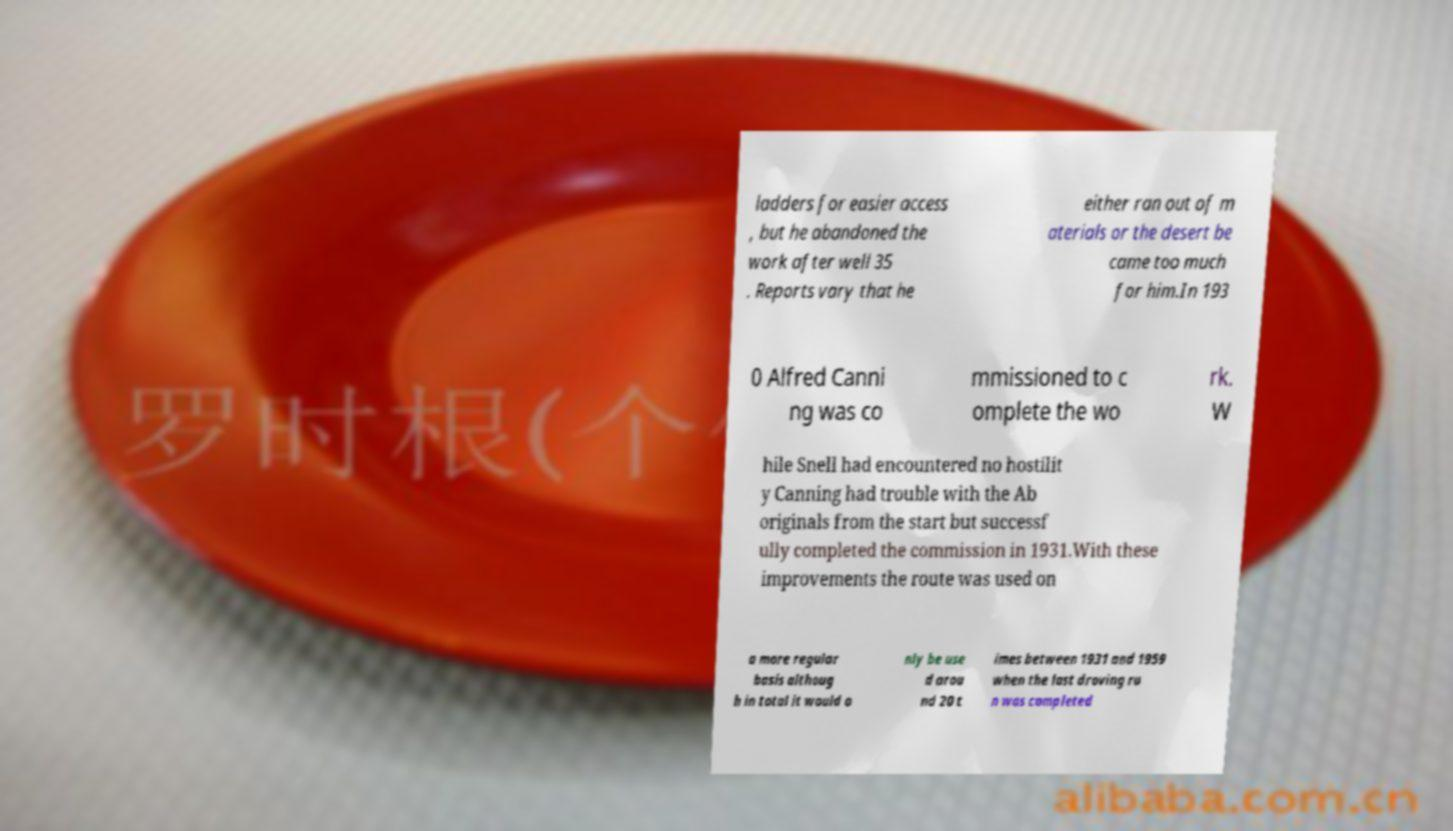Can you accurately transcribe the text from the provided image for me? ladders for easier access , but he abandoned the work after well 35 . Reports vary that he either ran out of m aterials or the desert be came too much for him.In 193 0 Alfred Canni ng was co mmissioned to c omplete the wo rk. W hile Snell had encountered no hostilit y Canning had trouble with the Ab originals from the start but successf ully completed the commission in 1931.With these improvements the route was used on a more regular basis althoug h in total it would o nly be use d arou nd 20 t imes between 1931 and 1959 when the last droving ru n was completed 